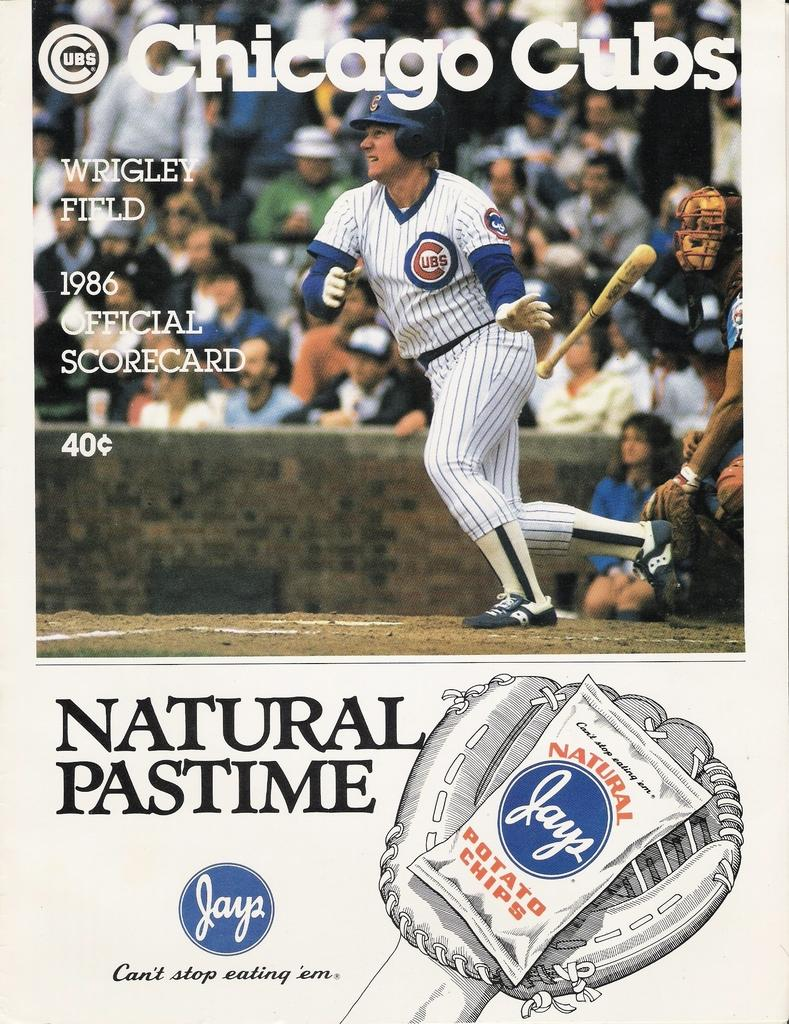Provide a one-sentence caption for the provided image. Chicago cubs magazine with nature pastime chips at the bottom. 